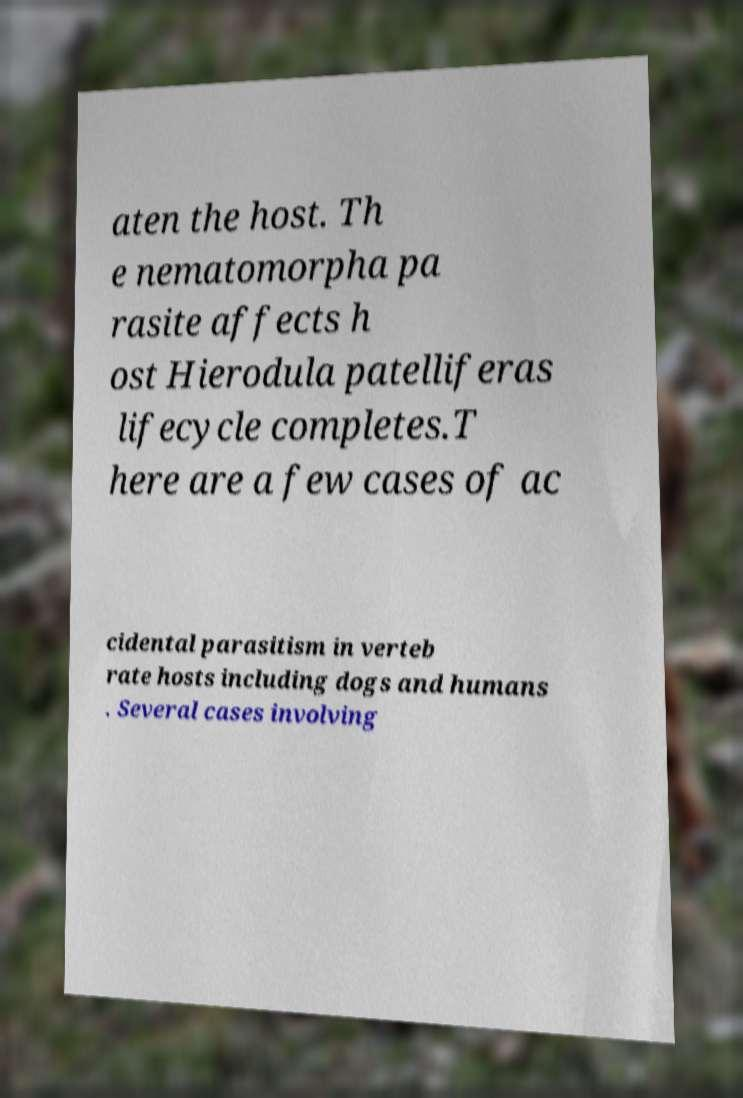Can you accurately transcribe the text from the provided image for me? aten the host. Th e nematomorpha pa rasite affects h ost Hierodula patelliferas lifecycle completes.T here are a few cases of ac cidental parasitism in verteb rate hosts including dogs and humans . Several cases involving 